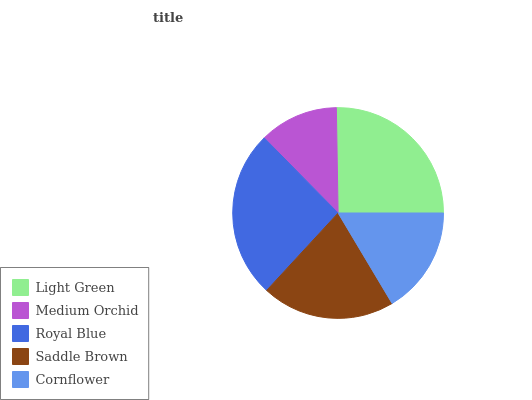Is Medium Orchid the minimum?
Answer yes or no. Yes. Is Royal Blue the maximum?
Answer yes or no. Yes. Is Royal Blue the minimum?
Answer yes or no. No. Is Medium Orchid the maximum?
Answer yes or no. No. Is Royal Blue greater than Medium Orchid?
Answer yes or no. Yes. Is Medium Orchid less than Royal Blue?
Answer yes or no. Yes. Is Medium Orchid greater than Royal Blue?
Answer yes or no. No. Is Royal Blue less than Medium Orchid?
Answer yes or no. No. Is Saddle Brown the high median?
Answer yes or no. Yes. Is Saddle Brown the low median?
Answer yes or no. Yes. Is Royal Blue the high median?
Answer yes or no. No. Is Light Green the low median?
Answer yes or no. No. 